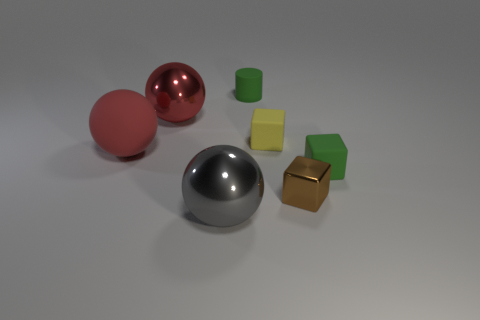Are there any tiny brown metal cubes to the left of the rubber ball?
Provide a short and direct response. No. Is the material of the green cube the same as the gray sphere?
Keep it short and to the point. No. What is the color of the other metallic thing that is the same shape as the gray object?
Make the answer very short. Red. Does the big metal object in front of the yellow matte thing have the same color as the tiny metal object?
Your answer should be very brief. No. There is a metal object that is the same color as the matte ball; what is its shape?
Give a very brief answer. Sphere. How many large things are the same material as the cylinder?
Your answer should be compact. 1. How many tiny green matte cylinders are in front of the red metallic object?
Offer a very short reply. 0. How big is the green matte cube?
Give a very brief answer. Small. What is the color of the cylinder that is the same size as the brown object?
Your response must be concise. Green. Are there any tiny metal blocks of the same color as the tiny cylinder?
Give a very brief answer. No. 